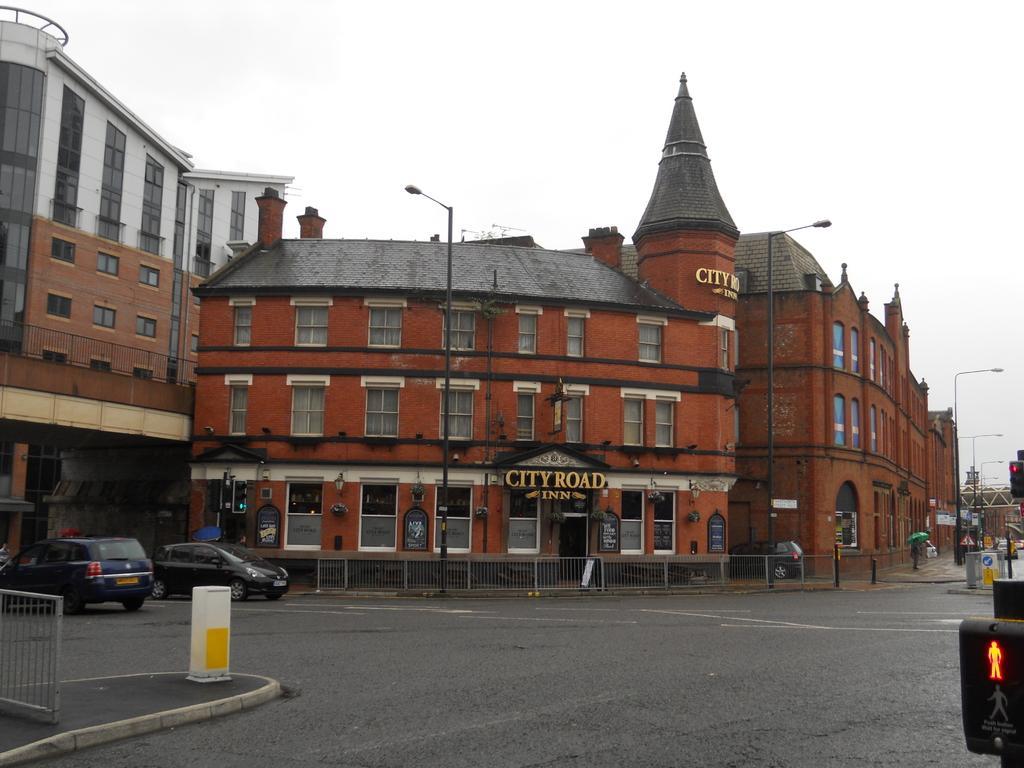In one or two sentences, can you explain what this image depicts? In this image in the center there are some buildings, poles, lights, railing and also there are some persons who are walking. On the left side there are some vehicles and on the right side there are some traffic signals, at the bottom there is a road and at the top of the image there is sky. 